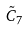Convert formula to latex. <formula><loc_0><loc_0><loc_500><loc_500>\tilde { C } _ { 7 }</formula> 